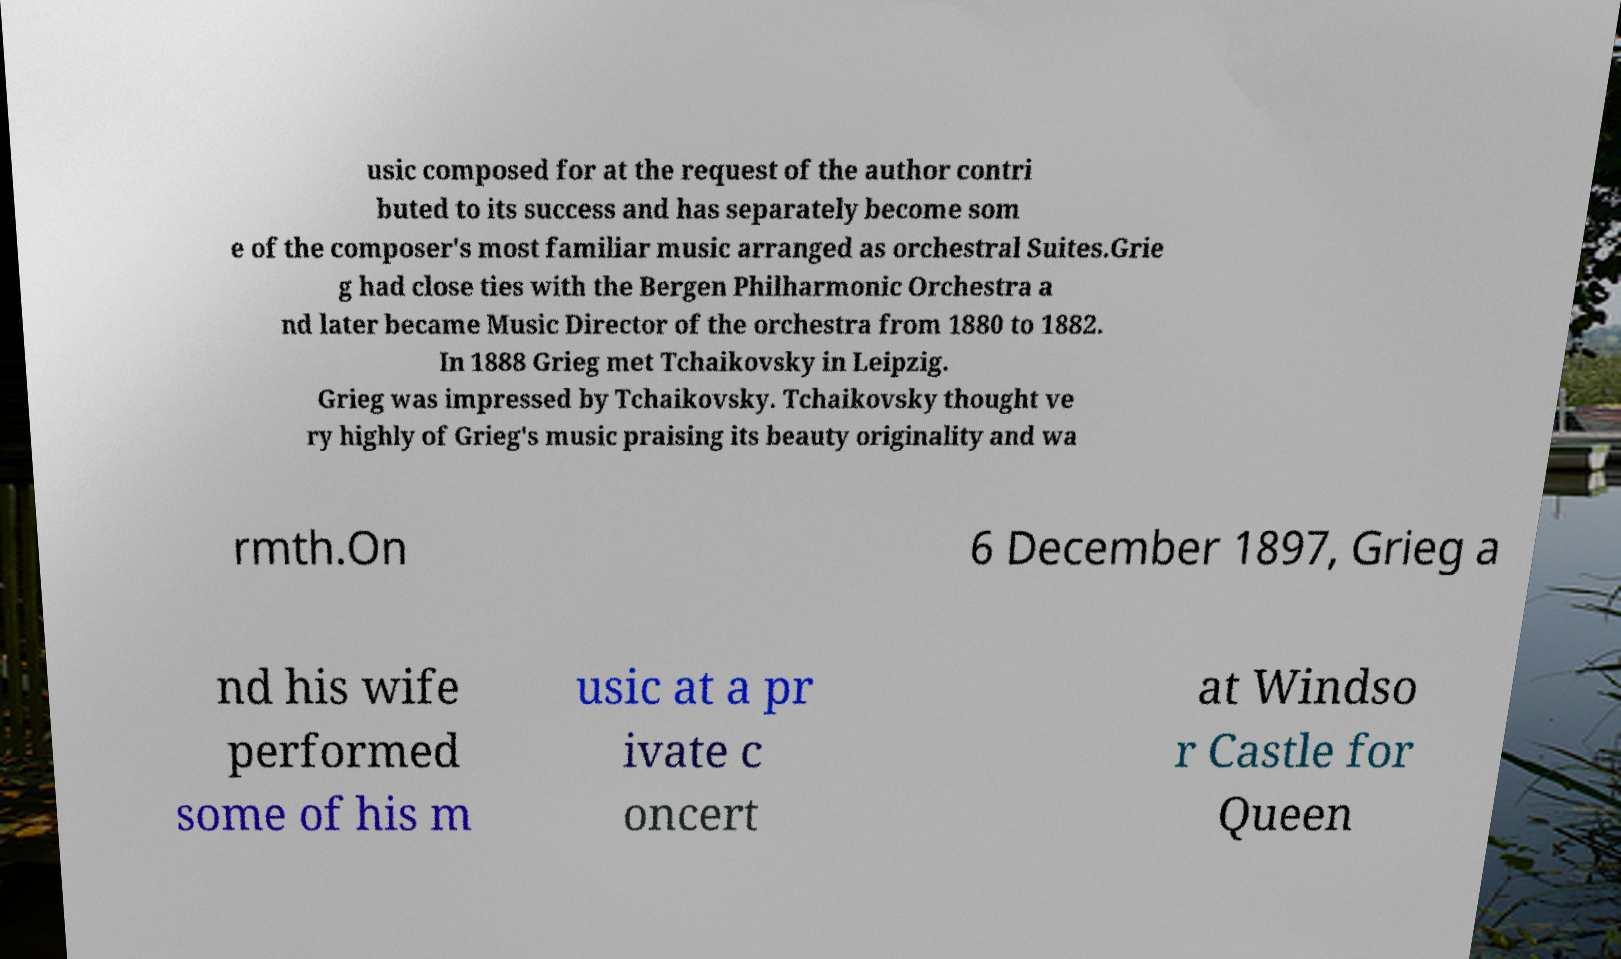I need the written content from this picture converted into text. Can you do that? usic composed for at the request of the author contri buted to its success and has separately become som e of the composer's most familiar music arranged as orchestral Suites.Grie g had close ties with the Bergen Philharmonic Orchestra a nd later became Music Director of the orchestra from 1880 to 1882. In 1888 Grieg met Tchaikovsky in Leipzig. Grieg was impressed by Tchaikovsky. Tchaikovsky thought ve ry highly of Grieg's music praising its beauty originality and wa rmth.On 6 December 1897, Grieg a nd his wife performed some of his m usic at a pr ivate c oncert at Windso r Castle for Queen 